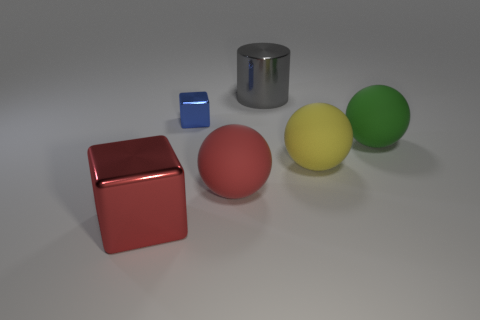Add 2 cylinders. How many objects exist? 8 Subtract all cubes. How many objects are left? 4 Add 6 blue metallic things. How many blue metallic things are left? 7 Add 4 big gray things. How many big gray things exist? 5 Subtract 0 brown cylinders. How many objects are left? 6 Subtract all small red metallic objects. Subtract all gray cylinders. How many objects are left? 5 